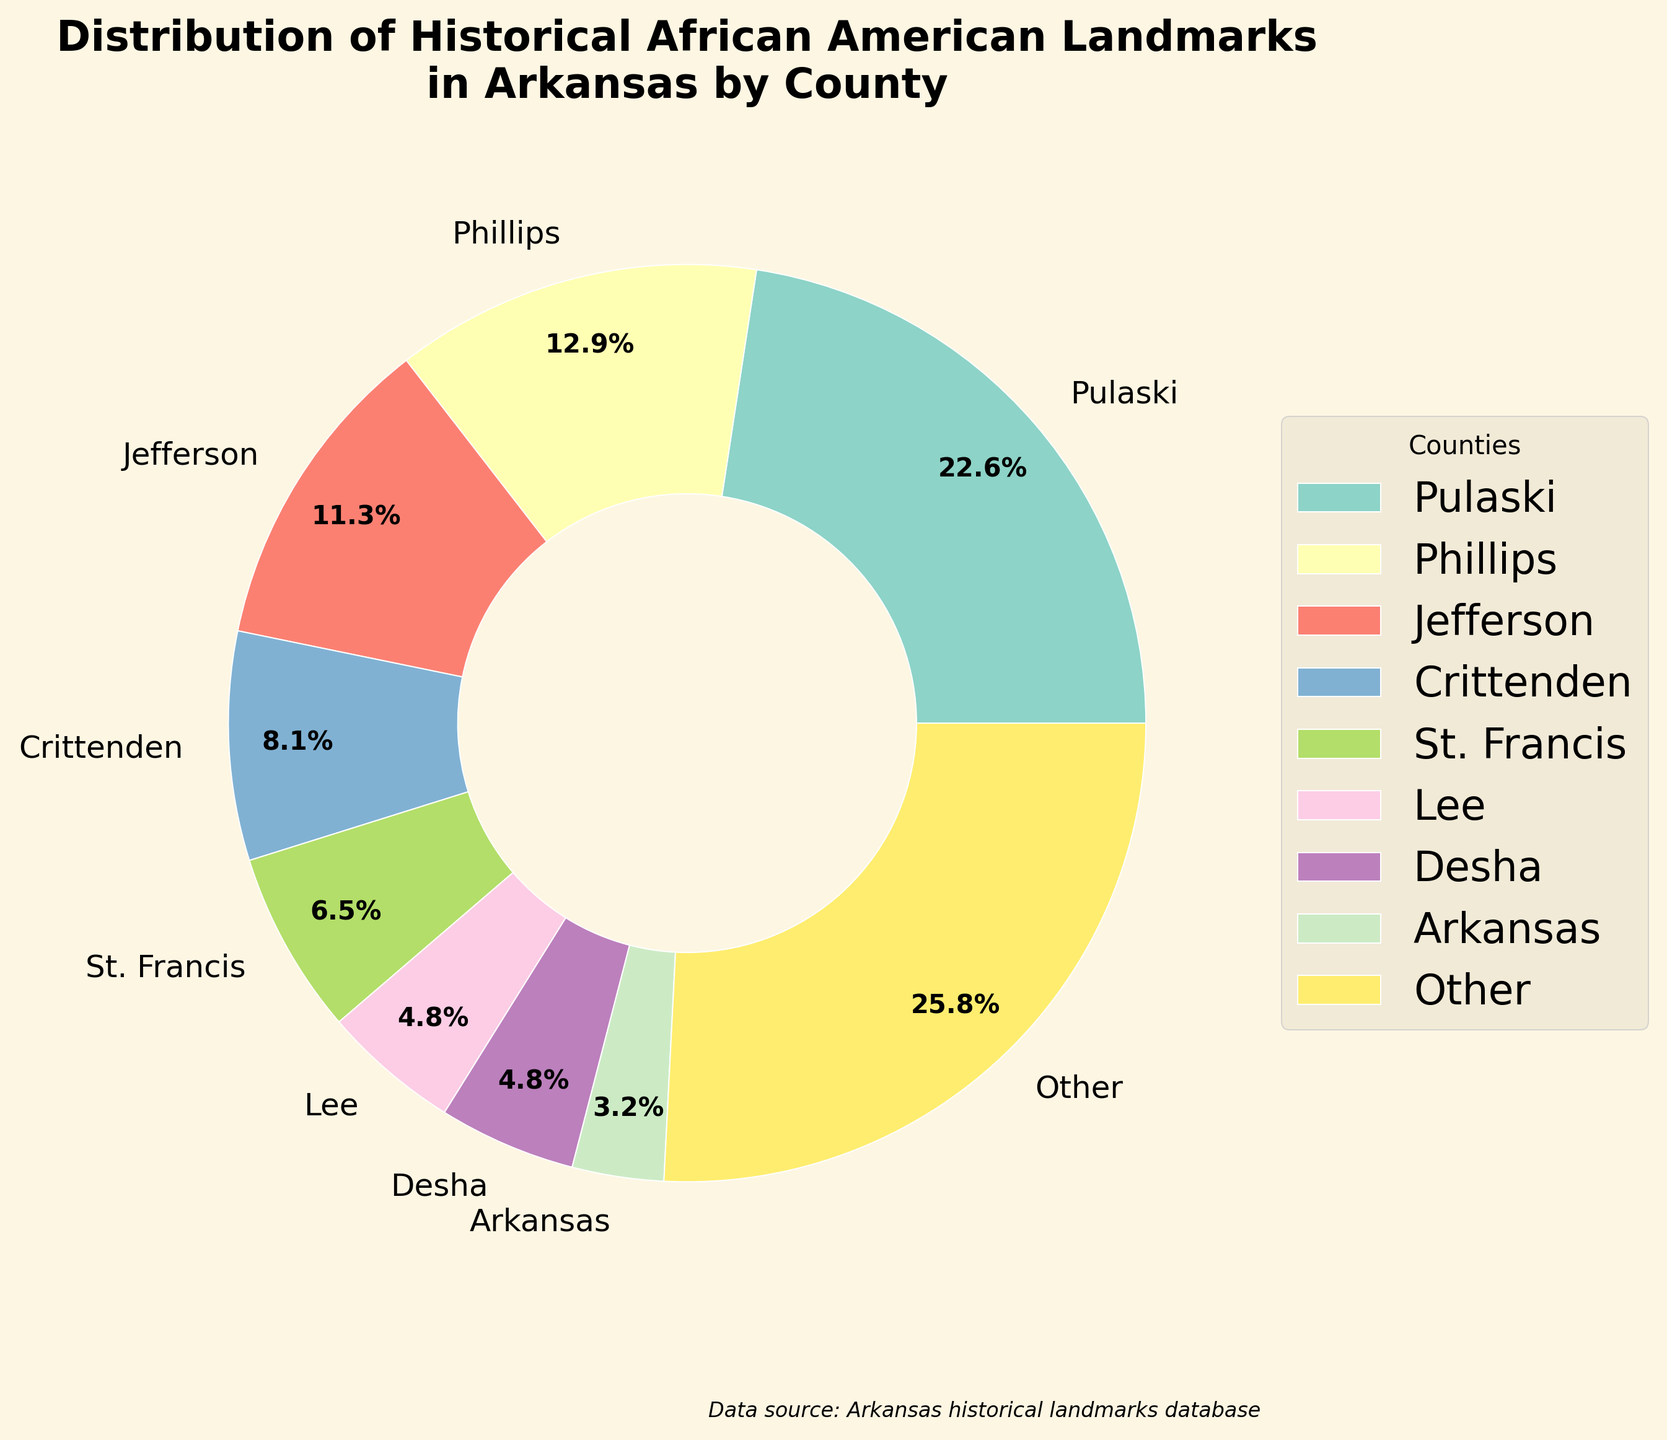What percentage of historical African American landmarks in Arkansas are located in Pulaski County? According to the pie chart, Pulaski County has the largest portion of landmarks. The percentage is directly indicated on the slice representing Pulaski County.
Answer: 34.1% How many counties have fewer historical African American landmarks than Pulaski County? By observing the chart, Pulaski County is the largest slice. Counting the number of smaller slices and excluding Pulaski gives us the total number of counties with fewer landmarks.
Answer: 19 Which county, among the top 8, has the second highest percentage of historical African American landmarks? The pie chart shows that the second largest slice, after Pulaski County, belongs to Phillips County.
Answer: Phillips What is the combined percentage of historical African American landmarks in Jefferson and Crittenden counties? Jefferson has 17.1% and Crittenden has 12.2%. Adding these two percentages gives the combined value.
Answer: 17.1% + 12.2% = 29.3% Are there more counties with 2 or more historical African American landmarks or fewer than 2? The chart shows several slices each with 2 or more landmarks, count these and compare to either count of slices representing fewer than 2 landmarks.
Answer: More counties have 2 or more landmarks What is the average number of historical African American landmarks in the top 5 counties? Pulaski (14), Phillips (8), Jefferson (7), Crittenden (5), and St. Francis (4). The sum is 14+8+7+5+4 = 38, and dividing by 5 gives 38 / 5 = 7.6.
Answer: 7.6 Which county has a visually similar size in comparison to Desha County in terms of landmarks? Observing the pie chart, Desha County’s slice appears similar in size to the slices representing Drew, Monroe, Lincoln, and Chicot counties.
Answer: Drew, Monroe, Lincoln, Chicot What is the percentage contribution of the 'Other' category in the pie chart? The 'Other' category combines all remaining counties beyond the top 8. The chart indicates this category's percentage.
Answer: 7.3% Which visual attributes help identify individual slices in the pie chart? The county names are labeled, different colors are used for each slice, and the size of each slice indicates its proportion.
Answer: Labels, colors, slice size How does the number of landmarks in Lee County compare to the number in Arkansas County? By looking at the chart, Lee County has a larger slice than Arkansas County, hence it has more landmarks.
Answer: More 